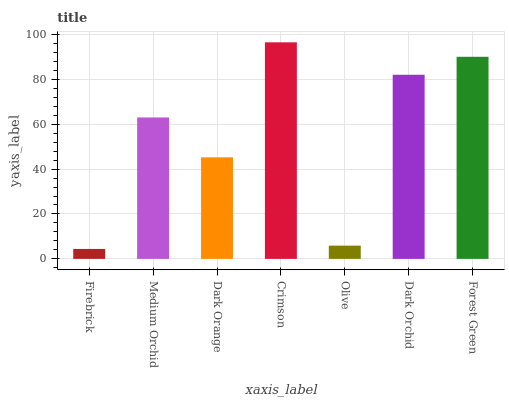Is Firebrick the minimum?
Answer yes or no. Yes. Is Crimson the maximum?
Answer yes or no. Yes. Is Medium Orchid the minimum?
Answer yes or no. No. Is Medium Orchid the maximum?
Answer yes or no. No. Is Medium Orchid greater than Firebrick?
Answer yes or no. Yes. Is Firebrick less than Medium Orchid?
Answer yes or no. Yes. Is Firebrick greater than Medium Orchid?
Answer yes or no. No. Is Medium Orchid less than Firebrick?
Answer yes or no. No. Is Medium Orchid the high median?
Answer yes or no. Yes. Is Medium Orchid the low median?
Answer yes or no. Yes. Is Firebrick the high median?
Answer yes or no. No. Is Dark Orchid the low median?
Answer yes or no. No. 